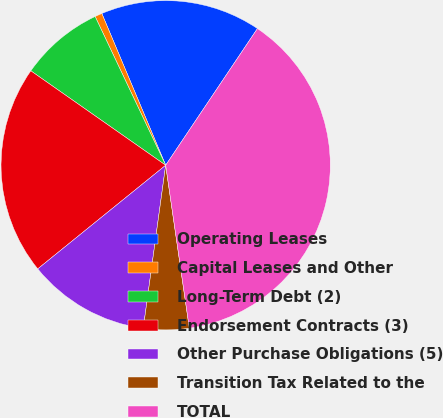<chart> <loc_0><loc_0><loc_500><loc_500><pie_chart><fcel>Operating Leases<fcel>Capital Leases and Other<fcel>Long-Term Debt (2)<fcel>Endorsement Contracts (3)<fcel>Other Purchase Obligations (5)<fcel>Transition Tax Related to the<fcel>TOTAL<nl><fcel>15.75%<fcel>0.71%<fcel>8.23%<fcel>20.56%<fcel>11.99%<fcel>4.47%<fcel>38.3%<nl></chart> 